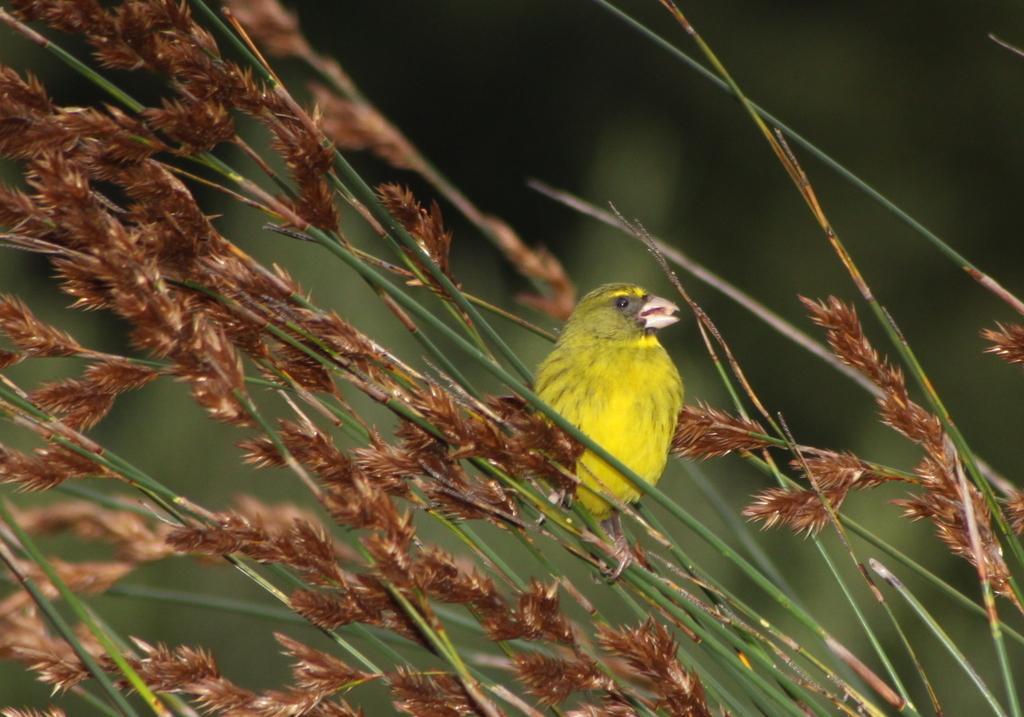In one or two sentences, can you explain what this image depicts? In this image we can see a bird. We can also see the stems, leaves and the background is blurred. 